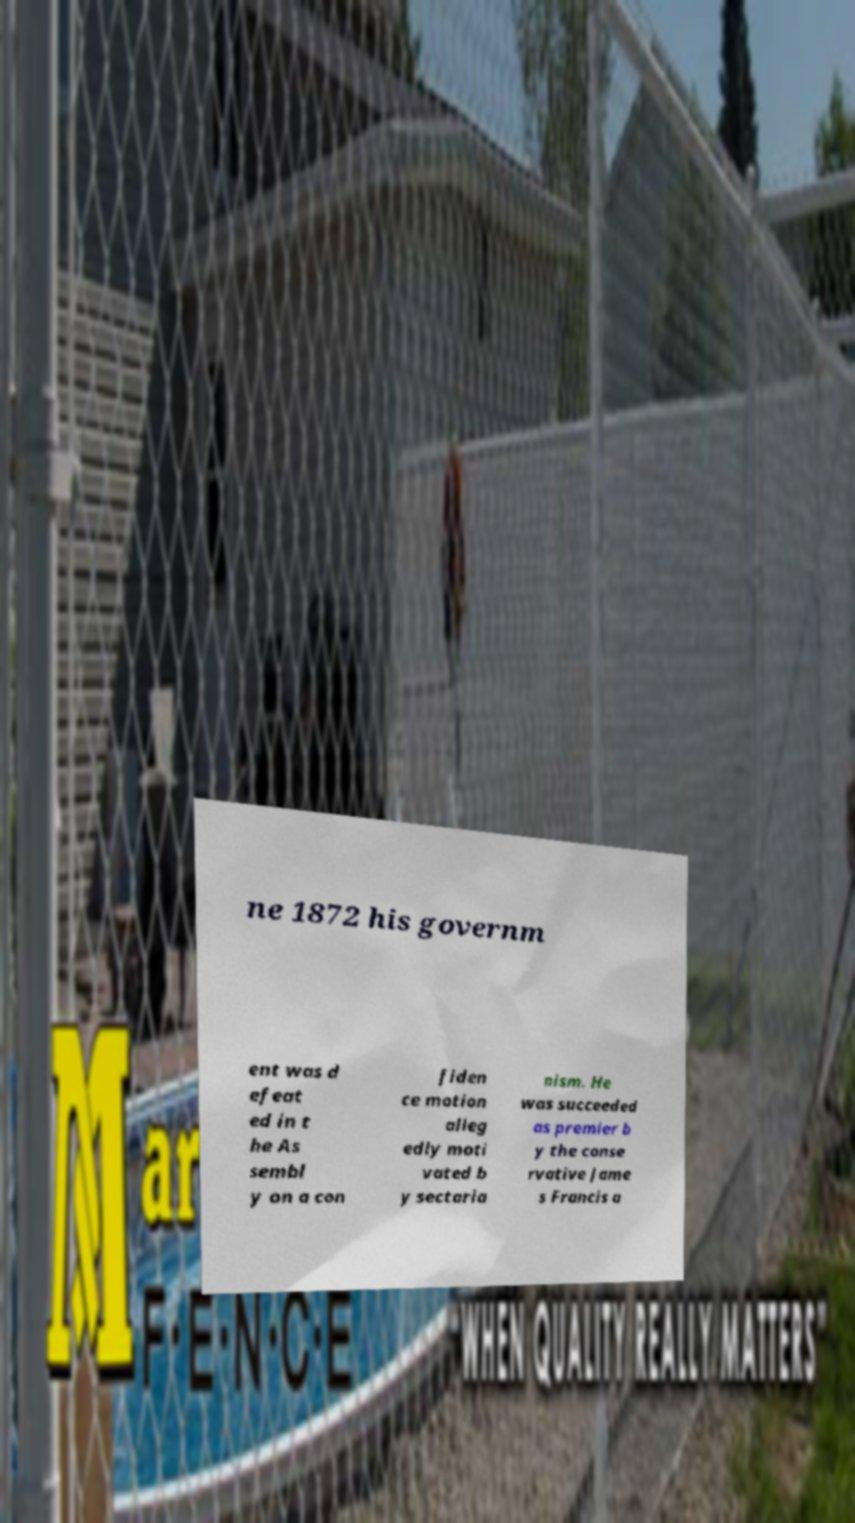Can you read and provide the text displayed in the image?This photo seems to have some interesting text. Can you extract and type it out for me? ne 1872 his governm ent was d efeat ed in t he As sembl y on a con fiden ce motion alleg edly moti vated b y sectaria nism. He was succeeded as premier b y the conse rvative Jame s Francis a 